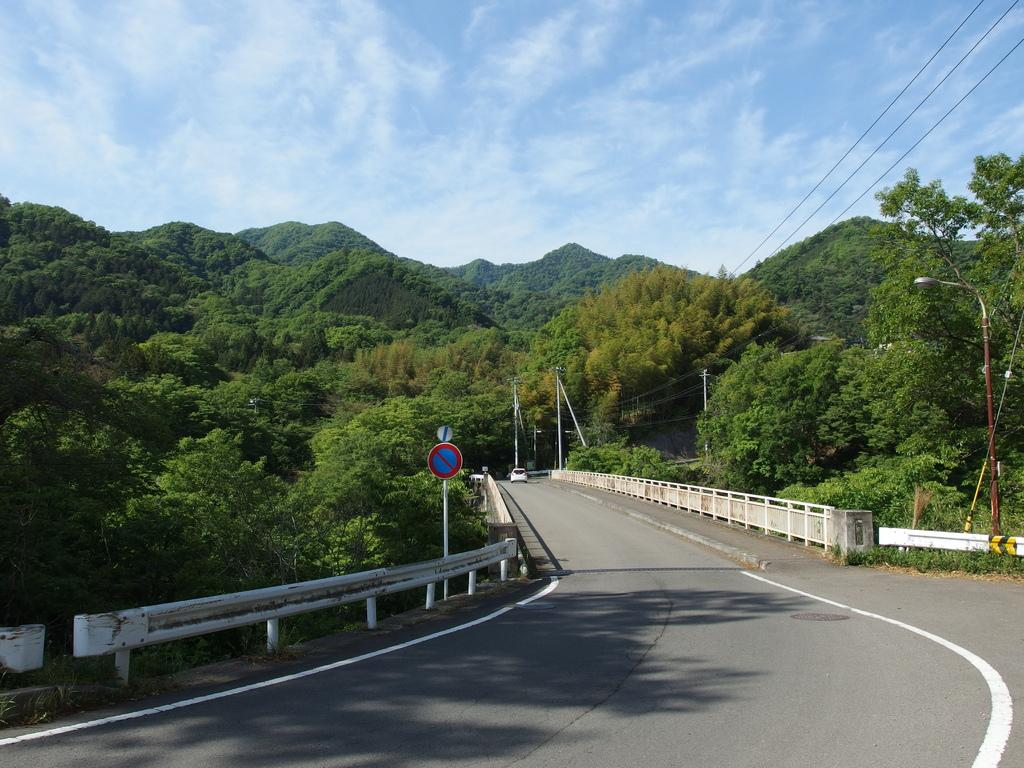What type of natural vegetation can be seen in the image? There are trees in the image. What type of geographical feature is visible in the image? There are hills visible in the image. What type of man-made structure is present in the image? There is a road in the image. What type of informational sign is present in the image? There is a sign board on the side of the road. What is the condition of the sky in the image? The sky is blue and cloudy in the image. What type of lighting is present in the image? There is a pole light in the image. Can you see any stitches on the trees in the image? There are no stitches present on the trees in the image. What type of picture is hanging on the wall in the image? There is no picture hanging on the wall in the image, as it is an outdoor scene with trees, hills, and a road. 